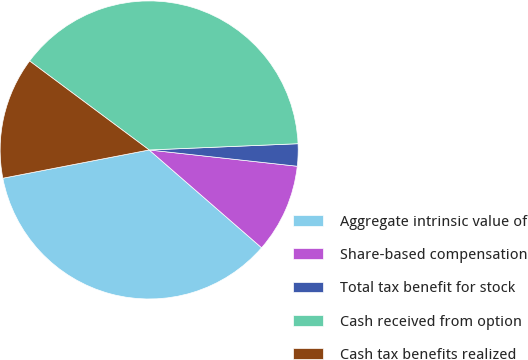<chart> <loc_0><loc_0><loc_500><loc_500><pie_chart><fcel>Aggregate intrinsic value of<fcel>Share-based compensation<fcel>Total tax benefit for stock<fcel>Cash received from option<fcel>Cash tax benefits realized<nl><fcel>35.57%<fcel>9.65%<fcel>2.41%<fcel>39.15%<fcel>13.22%<nl></chart> 